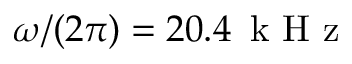Convert formula to latex. <formula><loc_0><loc_0><loc_500><loc_500>\omega / ( 2 \pi ) = 2 0 . 4 \, k H z</formula> 